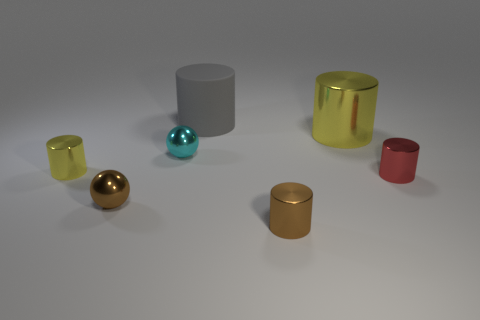What number of other things are there of the same material as the red cylinder
Keep it short and to the point. 5. Is there anything else that is the same shape as the big gray rubber object?
Provide a succinct answer. Yes. What is the size of the shiny sphere behind the red shiny object in front of the large gray cylinder?
Give a very brief answer. Small. Are there an equal number of tiny cyan shiny things that are to the right of the small red thing and tiny cyan objects that are on the right side of the big yellow metal object?
Your answer should be very brief. Yes. Is there any other thing that is the same size as the cyan metal object?
Provide a short and direct response. Yes. There is a large cylinder that is made of the same material as the small brown cylinder; what color is it?
Your answer should be very brief. Yellow. Is the material of the small cyan ball the same as the large thing to the left of the big yellow metallic object?
Your answer should be very brief. No. There is a small object that is in front of the red cylinder and on the right side of the brown shiny sphere; what color is it?
Make the answer very short. Brown. How many cylinders are either tiny yellow things or purple objects?
Offer a terse response. 1. There is a tiny red metal thing; does it have the same shape as the yellow metallic thing in front of the large yellow object?
Give a very brief answer. Yes. 